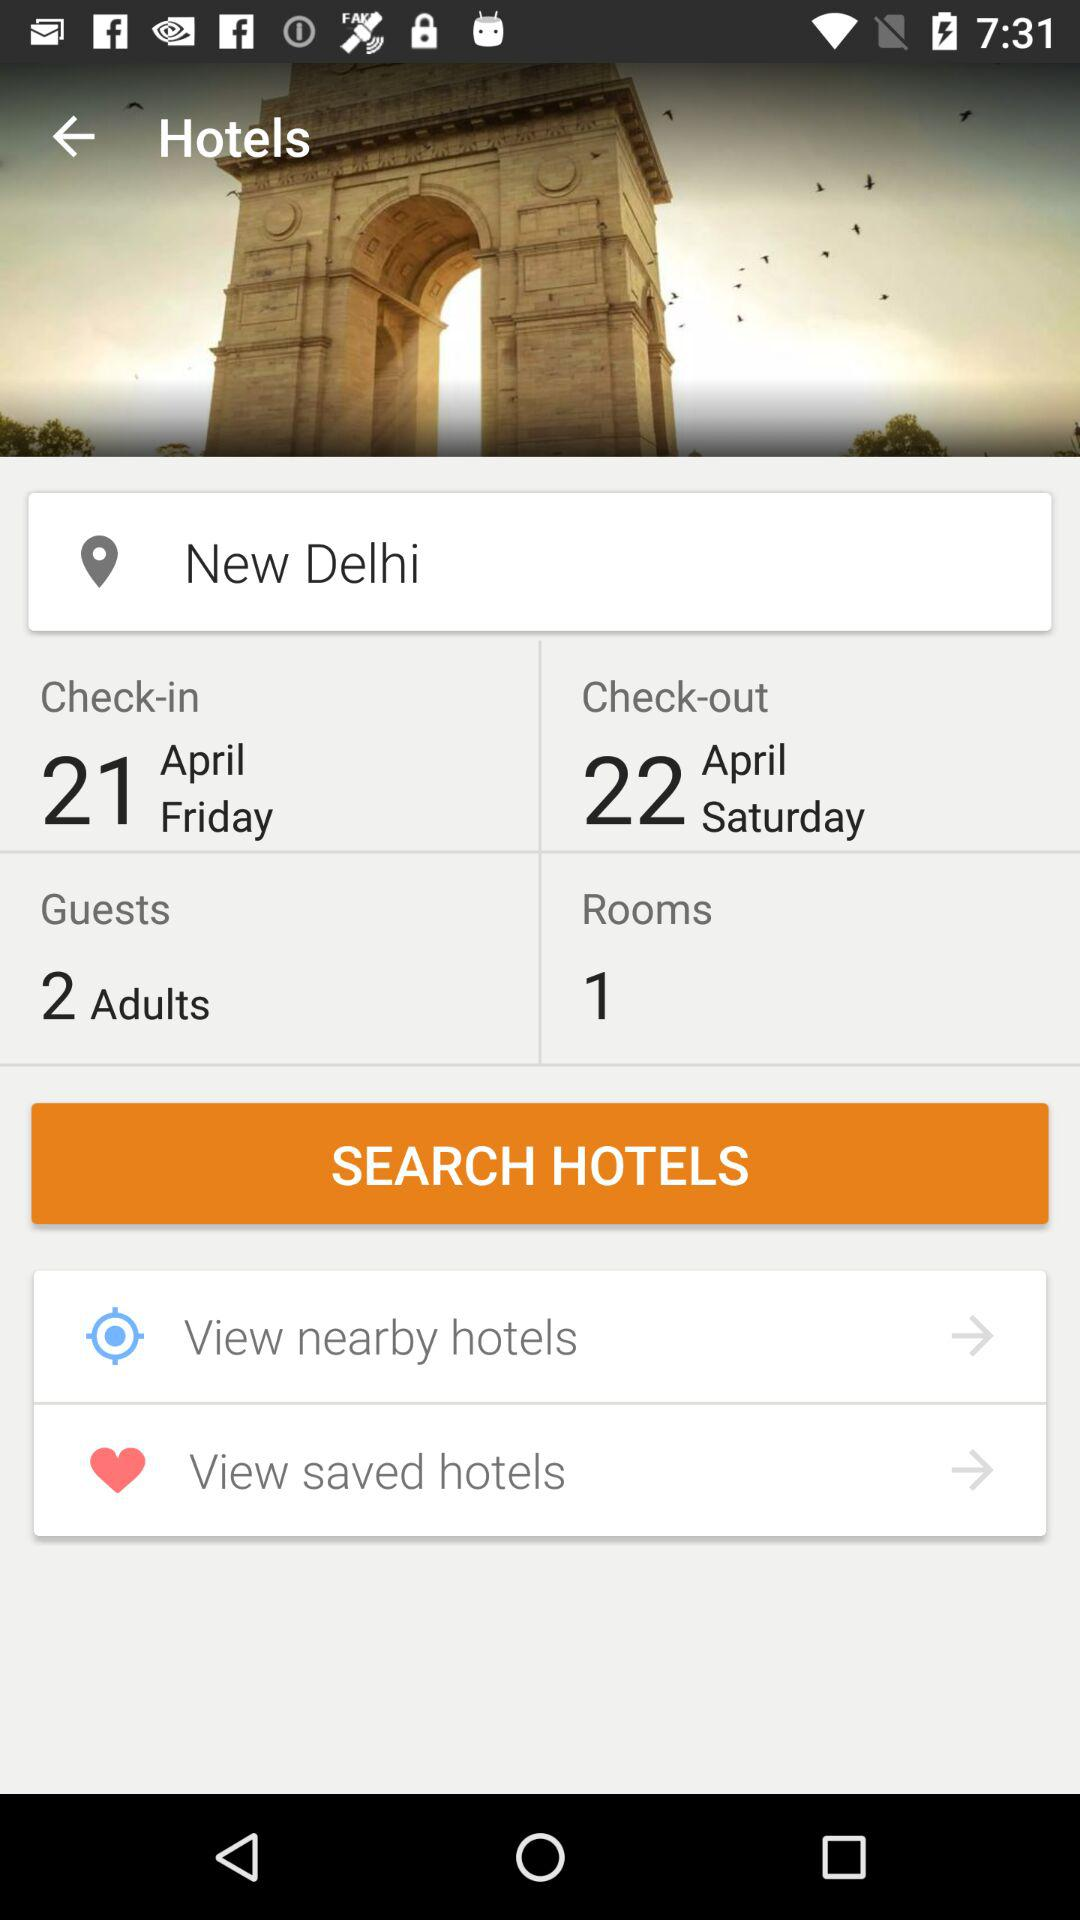How many adults are staying at the hotel?
Answer the question using a single word or phrase. 2 